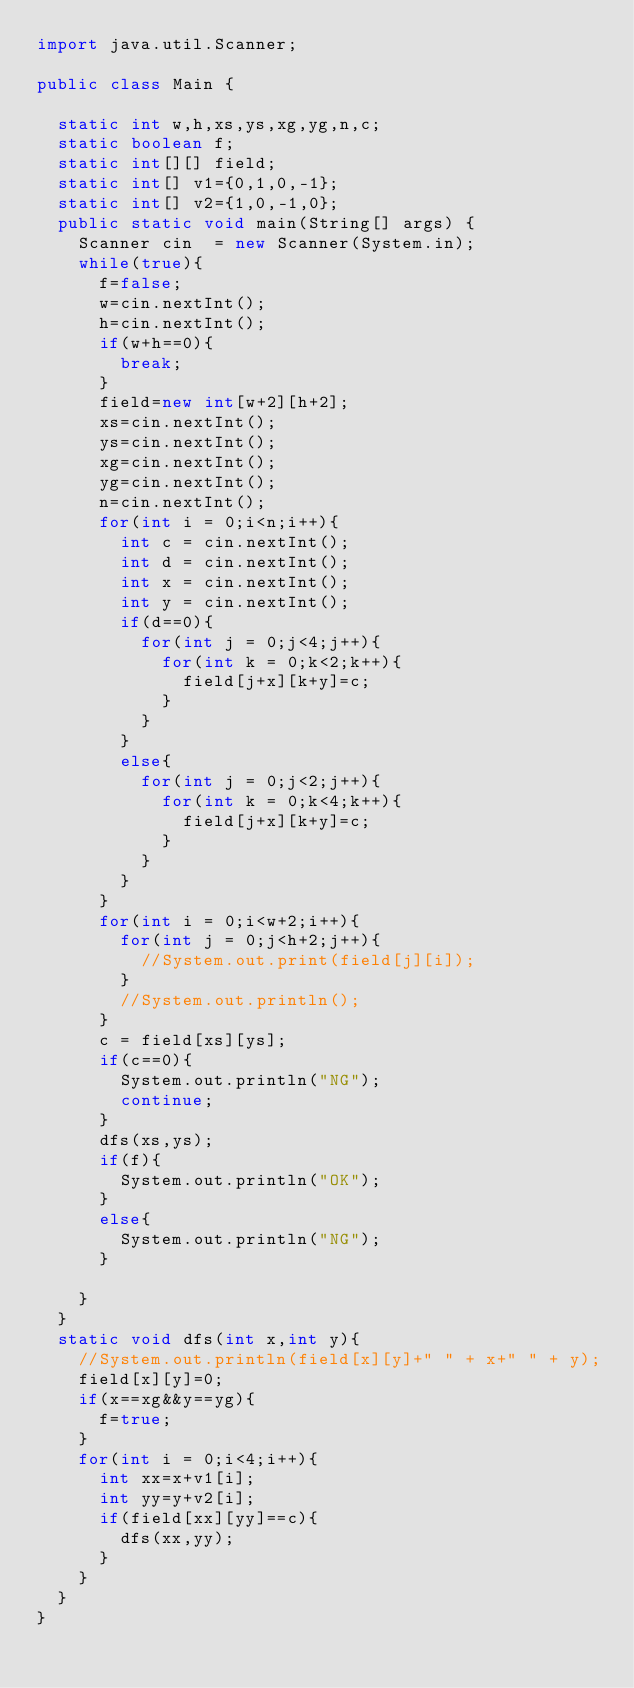<code> <loc_0><loc_0><loc_500><loc_500><_Java_>import java.util.Scanner;

public class Main {

	static int w,h,xs,ys,xg,yg,n,c;
	static boolean f;
	static int[][] field;
	static int[] v1={0,1,0,-1};
	static int[] v2={1,0,-1,0};
	public static void main(String[] args) {
		Scanner cin  = new Scanner(System.in);
		while(true){
			f=false;
			w=cin.nextInt();
			h=cin.nextInt();
			if(w+h==0){
				break;
			}
			field=new int[w+2][h+2];
			xs=cin.nextInt();
			ys=cin.nextInt();
			xg=cin.nextInt();
			yg=cin.nextInt();
			n=cin.nextInt();
			for(int i = 0;i<n;i++){
				int c = cin.nextInt();
				int d = cin.nextInt();
				int x = cin.nextInt();
				int y = cin.nextInt();
				if(d==0){
					for(int j = 0;j<4;j++){
						for(int k = 0;k<2;k++){
							field[j+x][k+y]=c;
						}
					}
				}
				else{
					for(int j = 0;j<2;j++){
						for(int k = 0;k<4;k++){
							field[j+x][k+y]=c;
						}
					}
				}
			}
			for(int i = 0;i<w+2;i++){
				for(int j = 0;j<h+2;j++){
					//System.out.print(field[j][i]);
				}
				//System.out.println();
			}
			c = field[xs][ys];
			if(c==0){
				System.out.println("NG");
				continue;
			}
			dfs(xs,ys);
			if(f){
				System.out.println("OK");
			}
			else{
				System.out.println("NG");
			}
				
		}
	}
	static void dfs(int x,int y){
		//System.out.println(field[x][y]+" " + x+" " + y);
		field[x][y]=0;
		if(x==xg&&y==yg){
			f=true;
		}
		for(int i = 0;i<4;i++){
			int xx=x+v1[i];
			int yy=y+v2[i];
			if(field[xx][yy]==c){
				dfs(xx,yy);
			}
		}
	}
}</code> 